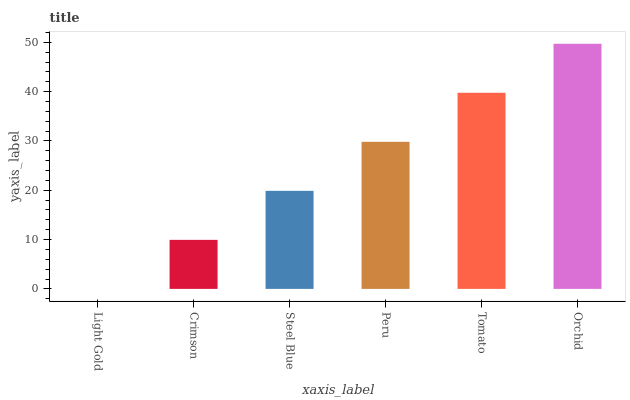Is Light Gold the minimum?
Answer yes or no. Yes. Is Orchid the maximum?
Answer yes or no. Yes. Is Crimson the minimum?
Answer yes or no. No. Is Crimson the maximum?
Answer yes or no. No. Is Crimson greater than Light Gold?
Answer yes or no. Yes. Is Light Gold less than Crimson?
Answer yes or no. Yes. Is Light Gold greater than Crimson?
Answer yes or no. No. Is Crimson less than Light Gold?
Answer yes or no. No. Is Peru the high median?
Answer yes or no. Yes. Is Steel Blue the low median?
Answer yes or no. Yes. Is Orchid the high median?
Answer yes or no. No. Is Orchid the low median?
Answer yes or no. No. 